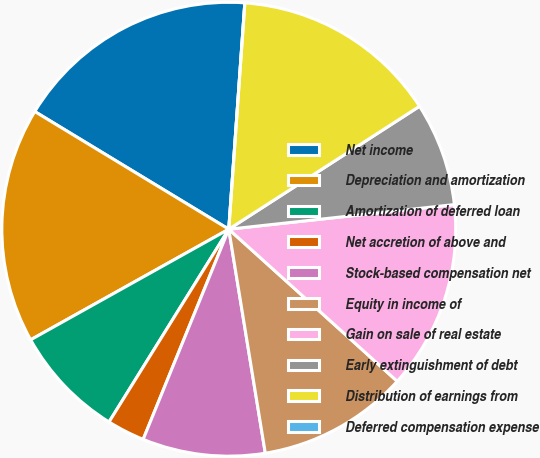<chart> <loc_0><loc_0><loc_500><loc_500><pie_chart><fcel>Net income<fcel>Depreciation and amortization<fcel>Amortization of deferred loan<fcel>Net accretion of above and<fcel>Stock-based compensation net<fcel>Equity in income of<fcel>Gain on sale of real estate<fcel>Early extinguishment of debt<fcel>Distribution of earnings from<fcel>Deferred compensation expense<nl><fcel>17.45%<fcel>16.78%<fcel>8.05%<fcel>2.69%<fcel>8.73%<fcel>10.74%<fcel>13.42%<fcel>7.38%<fcel>14.76%<fcel>0.0%<nl></chart> 